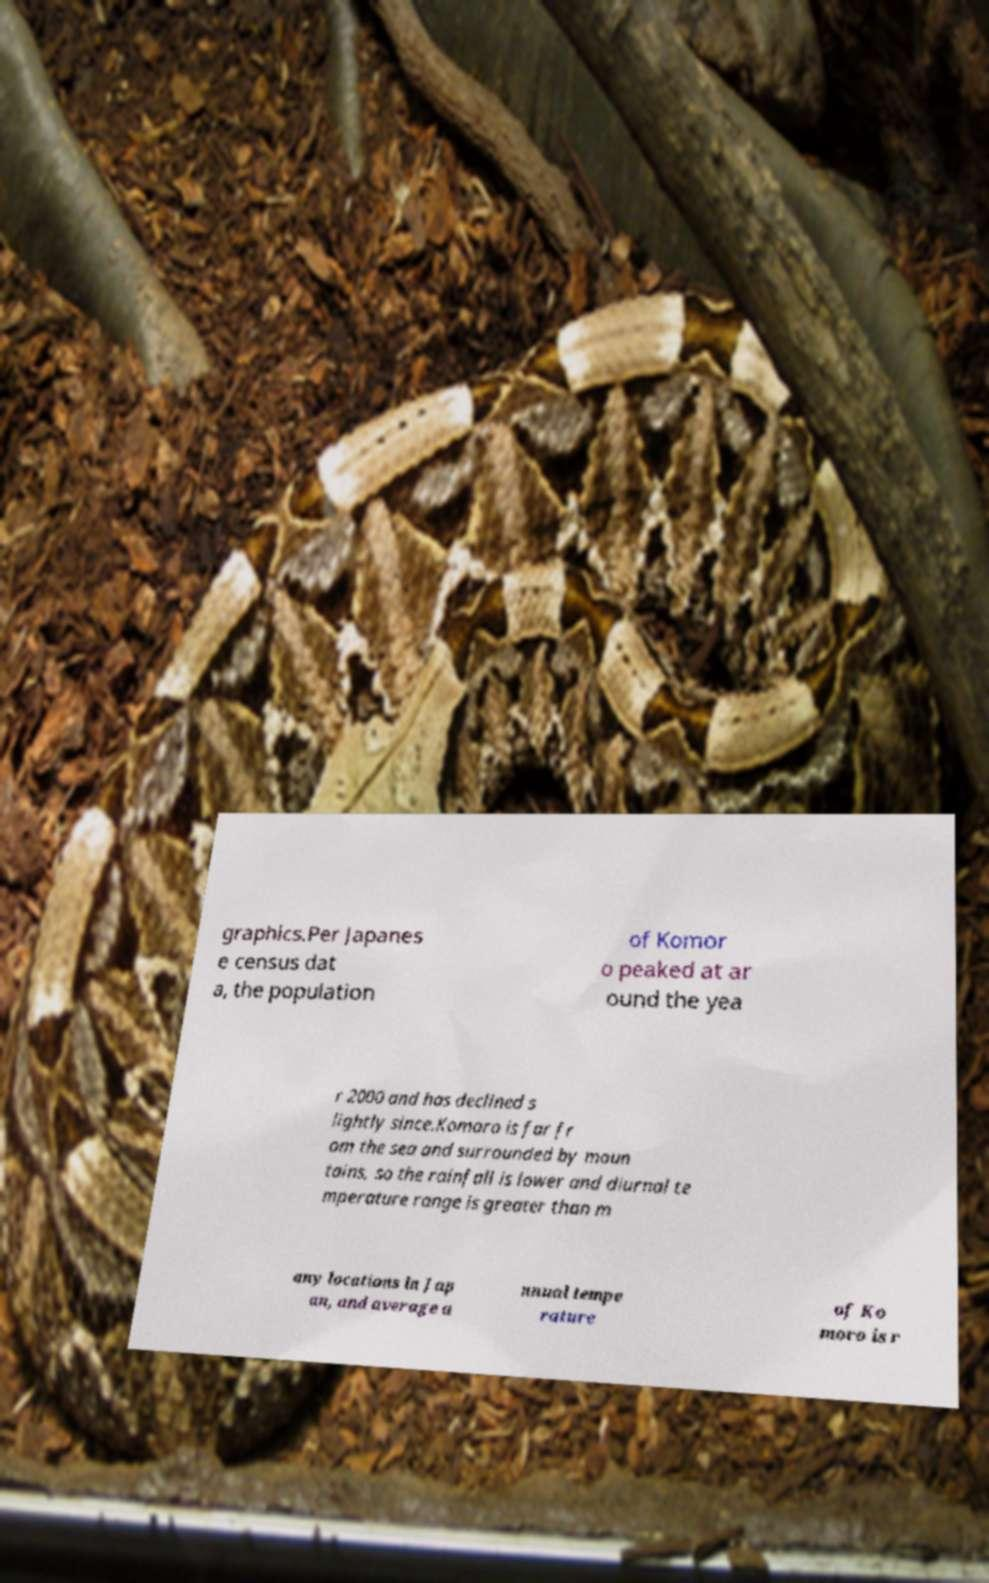Can you read and provide the text displayed in the image?This photo seems to have some interesting text. Can you extract and type it out for me? graphics.Per Japanes e census dat a, the population of Komor o peaked at ar ound the yea r 2000 and has declined s lightly since.Komoro is far fr om the sea and surrounded by moun tains, so the rainfall is lower and diurnal te mperature range is greater than m any locations in Jap an, and average a nnual tempe rature of Ko moro is r 